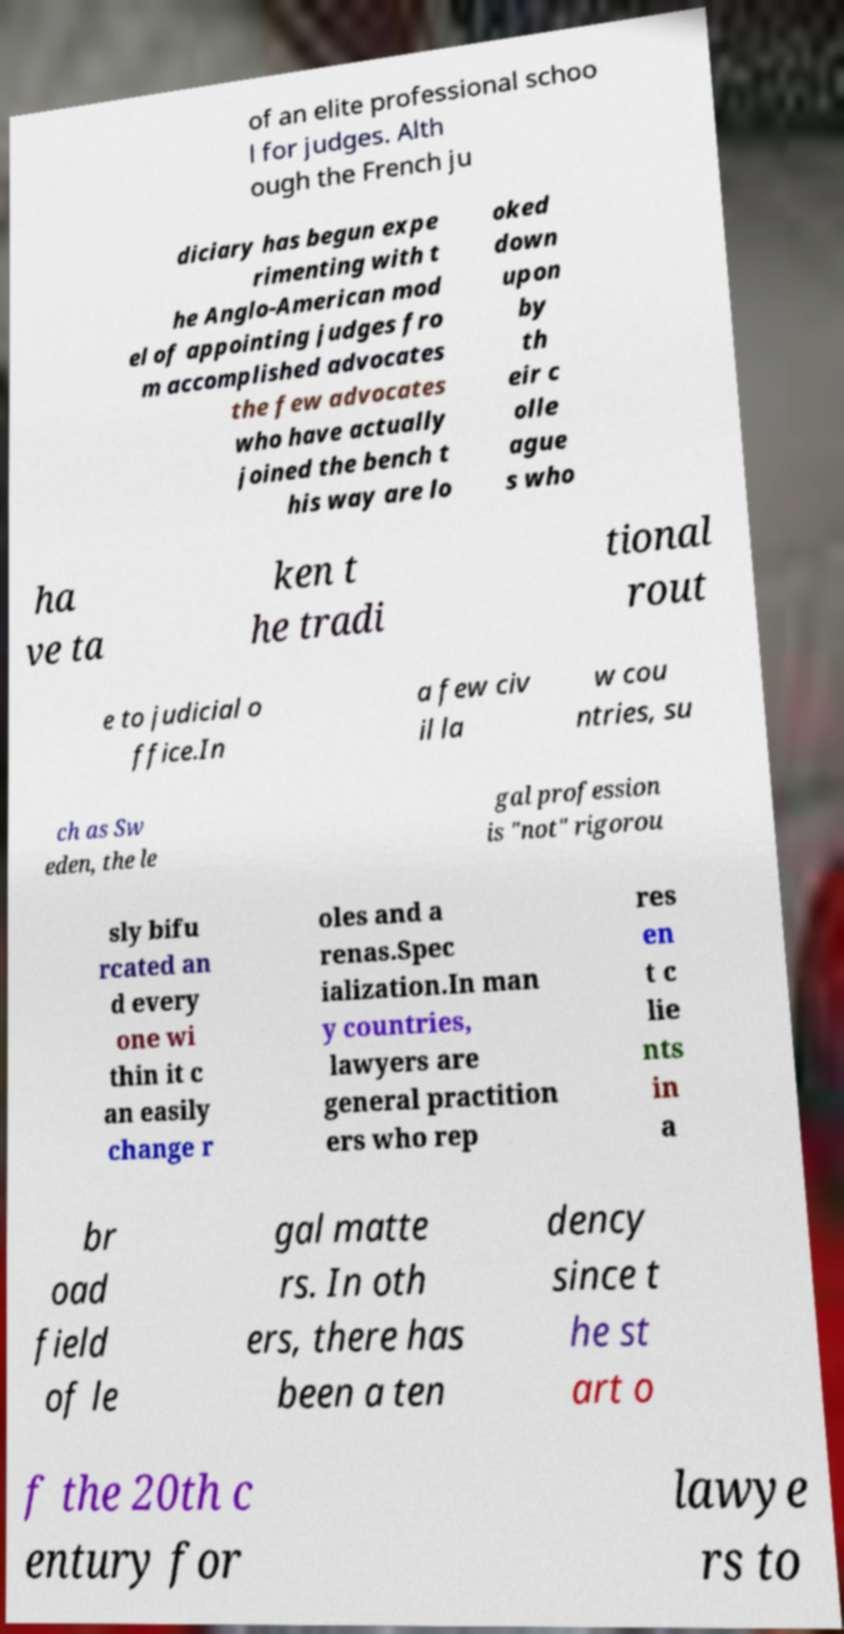Can you describe the format and layout of the text in the image? The text in the image is arranged in a column-aligned style with some words highlighted in different colors, making it visually distinctive. The fragments are aligned unevenly on either left or right side which makes the overall layout a bit confusing and challenging to read. 